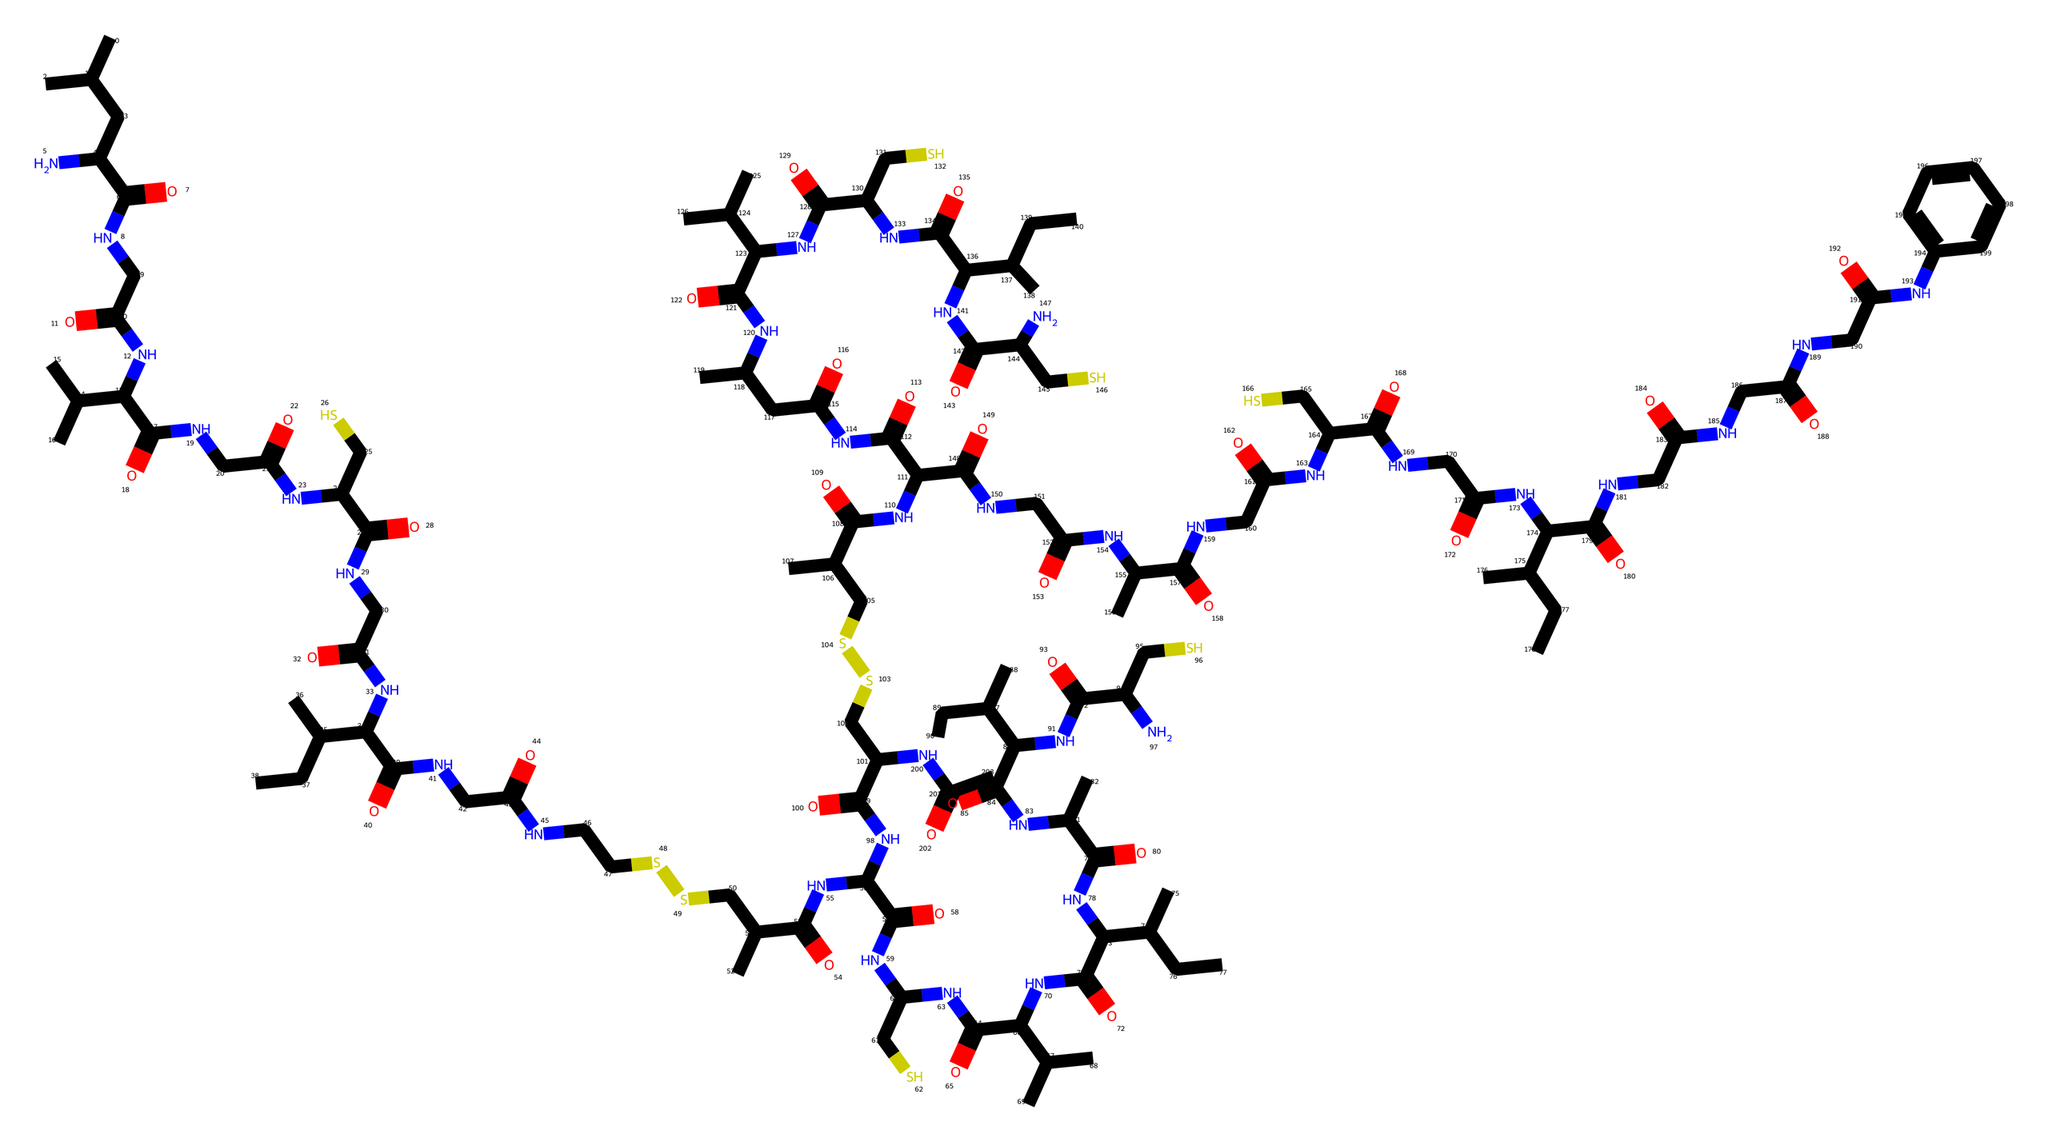What is the molecular formula of this compound? To determine the molecular formula, we need to count the number of each type of atom represented in the chemical structure. By analyzing the SMILES notation, we can identify carbon (C), hydrogen (H), nitrogen (N), and oxygen (O) atoms. In total, there are 25 C, 43 H, 8 N, and 8 O atoms. Thus, the molecular formula can be constructed as C25H43N8O8.
Answer: C25H43N8O8 How many nitrogen atoms are present in this chemical? In the provided SMILES, we can observe multiple occurrences of the nitrogen (N) atom. Counting these occurrences gives us a total of 8 nitrogen atoms present in the compound.
Answer: 8 What type of drug is insulin? Insulin is classified as a peptide hormone. It is a biological molecule composed of amino acids, primarily synthesizing the regulation of glucose levels in the body.
Answer: peptide hormone What distinguishes this insulin from other drugs? This insulin has a complex structure with multiple amino acid sequences, which contributes to its specificity and effectiveness in managing diabetes compared to simpler drugs. It contains several intricate connections and modifications that enhance its function, making it distinct in its action.
Answer: complex structure How many oxygen atoms are present in this chemical? By analyzing the SMILES notation, we look specifically for the oxygen (O) atom notations and count them. There are a total of 8 oxygen atoms indicated in the structure of this compound.
Answer: 8 Is this chemical structure linear or branched? The chemical structure represented by the SMILES indicates the presence of branching in its carbon chains, which makes it a branched structure rather than a linear one. This can be inferred from the presence of multiple carbon chains that diverge.
Answer: branched What is a common effect of insulin in diabetes management? Insulin's primary effect in diabetes management is to lower blood glucose levels. It facilitates the uptake of glucose into cells, which is essential for energy metabolism, especially in regulating blood sugar levels for individuals with diabetes.
Answer: lower blood glucose levels 